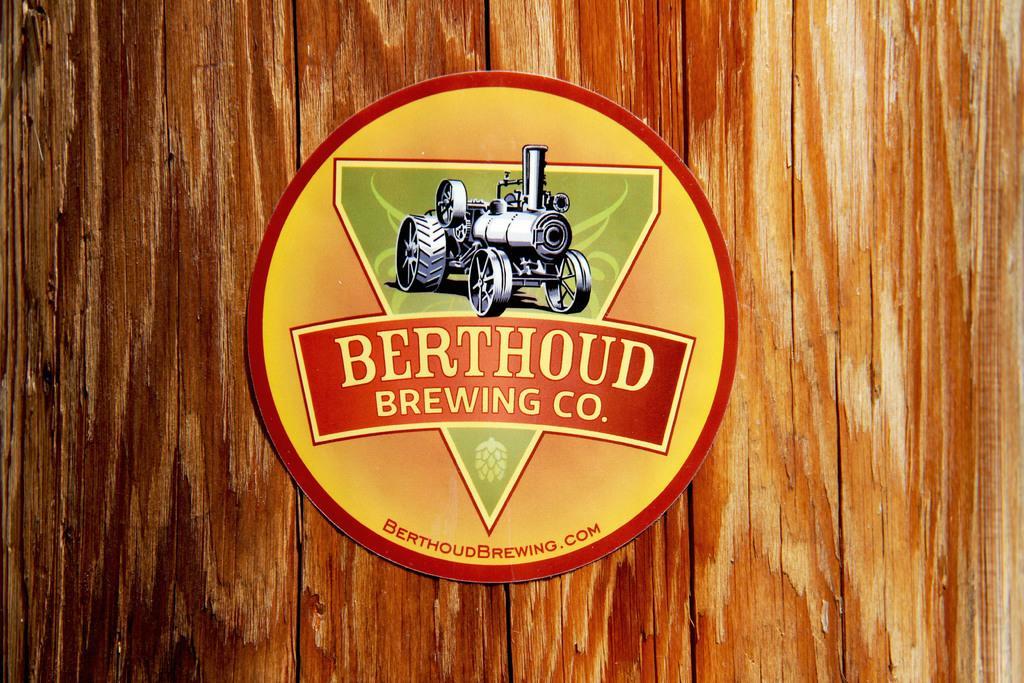Can you describe this image briefly? In this picture we can see a poster. We can see a vehicle on this poster. There is a wooden background. 